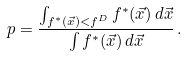<formula> <loc_0><loc_0><loc_500><loc_500>p = \frac { \int _ { f ^ { * } ( \vec { x } ) < f ^ { D } } f ^ { * } ( \vec { x } ) \, d \vec { x } } { \int f ^ { * } ( \vec { x } ) \, d \vec { x } } \, .</formula> 